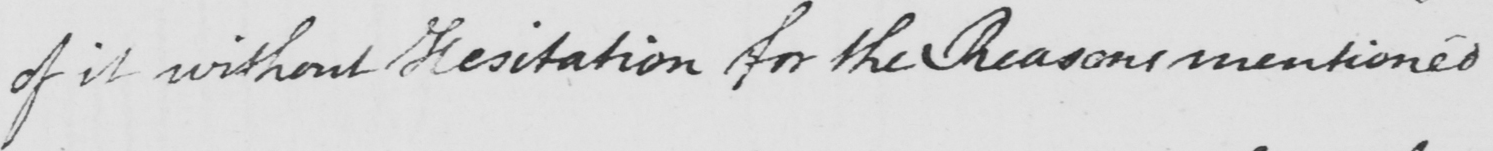What does this handwritten line say? of it without Hesitation for the Reasons mentioned 